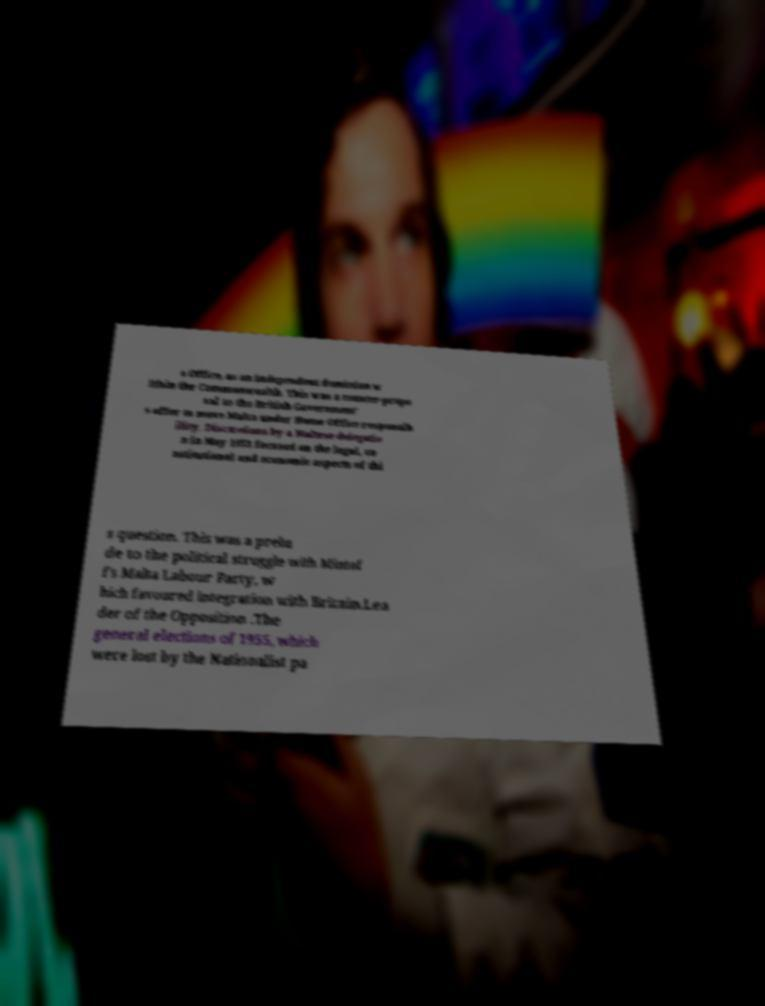Could you extract and type out the text from this image? s Office, as an independent dominion w ithin the Commonwealth. This was a counter-propo sal to the British Government' s offer to move Malta under Home Office responsib ility. Discussions by a Maltese delegatio n in May 1953 focused on the legal, co nstitutional and economic aspects of thi s question. This was a prelu de to the political struggle with Mintof f's Malta Labour Party, w hich favoured integration with Britain.Lea der of the Opposition .The general elections of 1955, which were lost by the Nationalist pa 